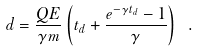Convert formula to latex. <formula><loc_0><loc_0><loc_500><loc_500>d = \frac { Q E } { \gamma m } \left ( t _ { d } + \frac { e ^ { - \gamma t _ { d } } - 1 } { \gamma } \right ) \ .</formula> 